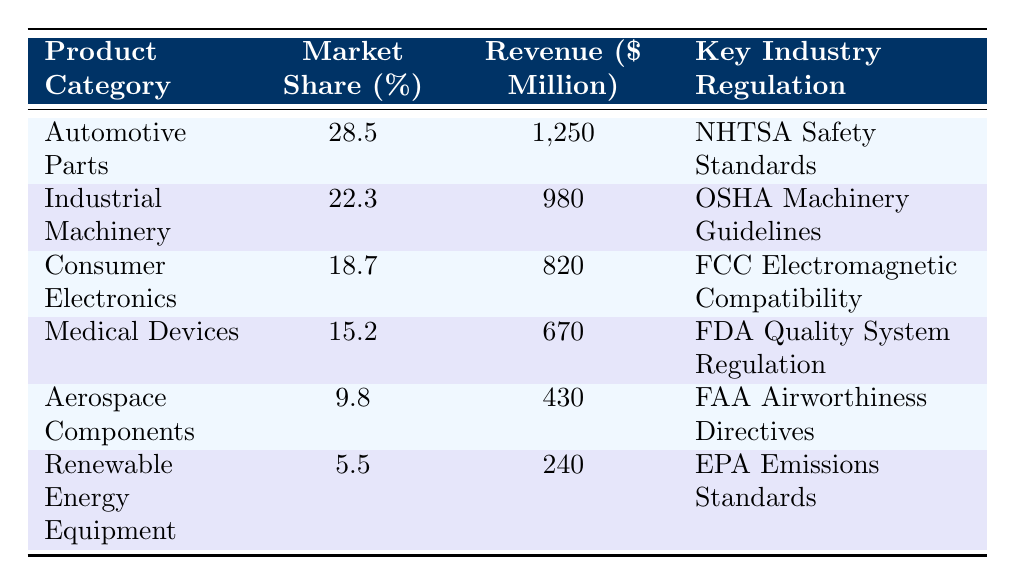What is the market share percentage of Consumer Electronics? The table lists the market share percentage for each product category. For Consumer Electronics, it specifically states 18.7%.
Answer: 18.7% Which product category has the highest revenue? By examining the revenue column, Automotive Parts shows the highest value at 1,250 million dollars, compared to other categories.
Answer: Automotive Parts What is the total revenue of the Renewable Energy Equipment and Aerospace Components combined? To find the total revenue, we sum the revenue of Renewable Energy Equipment (240 million) and Aerospace Components (430 million): 240 + 430 = 670 million dollars.
Answer: 670 million Is it true that Medical Devices have a higher market share than Aerospace Components? Comparing the market share percentages, Medical Devices have 15.2% while Aerospace Components have 9.8%, therefore, the statement is correct.
Answer: Yes What is the average market share percentage of the top three product categories? The top three product categories are Automotive Parts (28.5%), Industrial Machinery (22.3%), and Consumer Electronics (18.7%). Their total market share is 28.5 + 22.3 + 18.7 = 69.5%, and dividing by 3 gives an average of 69.5 / 3 = 23.17%.
Answer: 23.17% Which industry regulation is associated with the lowest revenue product category? The product category with the lowest revenue is Renewable Energy Equipment with 240 million dollars, and its associated regulation is EPA Emissions Standards.
Answer: EPA Emissions Standards What is the difference in revenue between Industrial Machinery and Medical Devices? Industrial Machinery has a revenue of 980 million dollars and Medical Devices have 670 million dollars. The difference is 980 - 670 = 310 million dollars.
Answer: 310 million If you rank the product categories by market share, what is the market share percentage of the second category? Arranging the market share percentages in descending order gives: Automotive Parts (28.5%), Industrial Machinery (22.3%), Consumer Electronics (18.7%), Medical Devices (15.2%), Aerospace Components (9.8%), and Renewable Energy Equipment (5.5%). Thus, the second category is Industrial Machinery with 22.3%.
Answer: 22.3% What is the total market share percentage of the lowest three product categories? The lowest three product categories in terms of market share are Aerospace Components (9.8%), Renewable Energy Equipment (5.5%), and Medical Devices (15.2%). Adding their market share: 9.8 + 5.5 + 15.2 = 30.5%.
Answer: 30.5% Are there any product categories that exceed 20% market share? By reviewing the market share percentages listed in the table, Automotive Parts (28.5%) and Industrial Machinery (22.3%) are the only two that exceed 20%.
Answer: Yes 